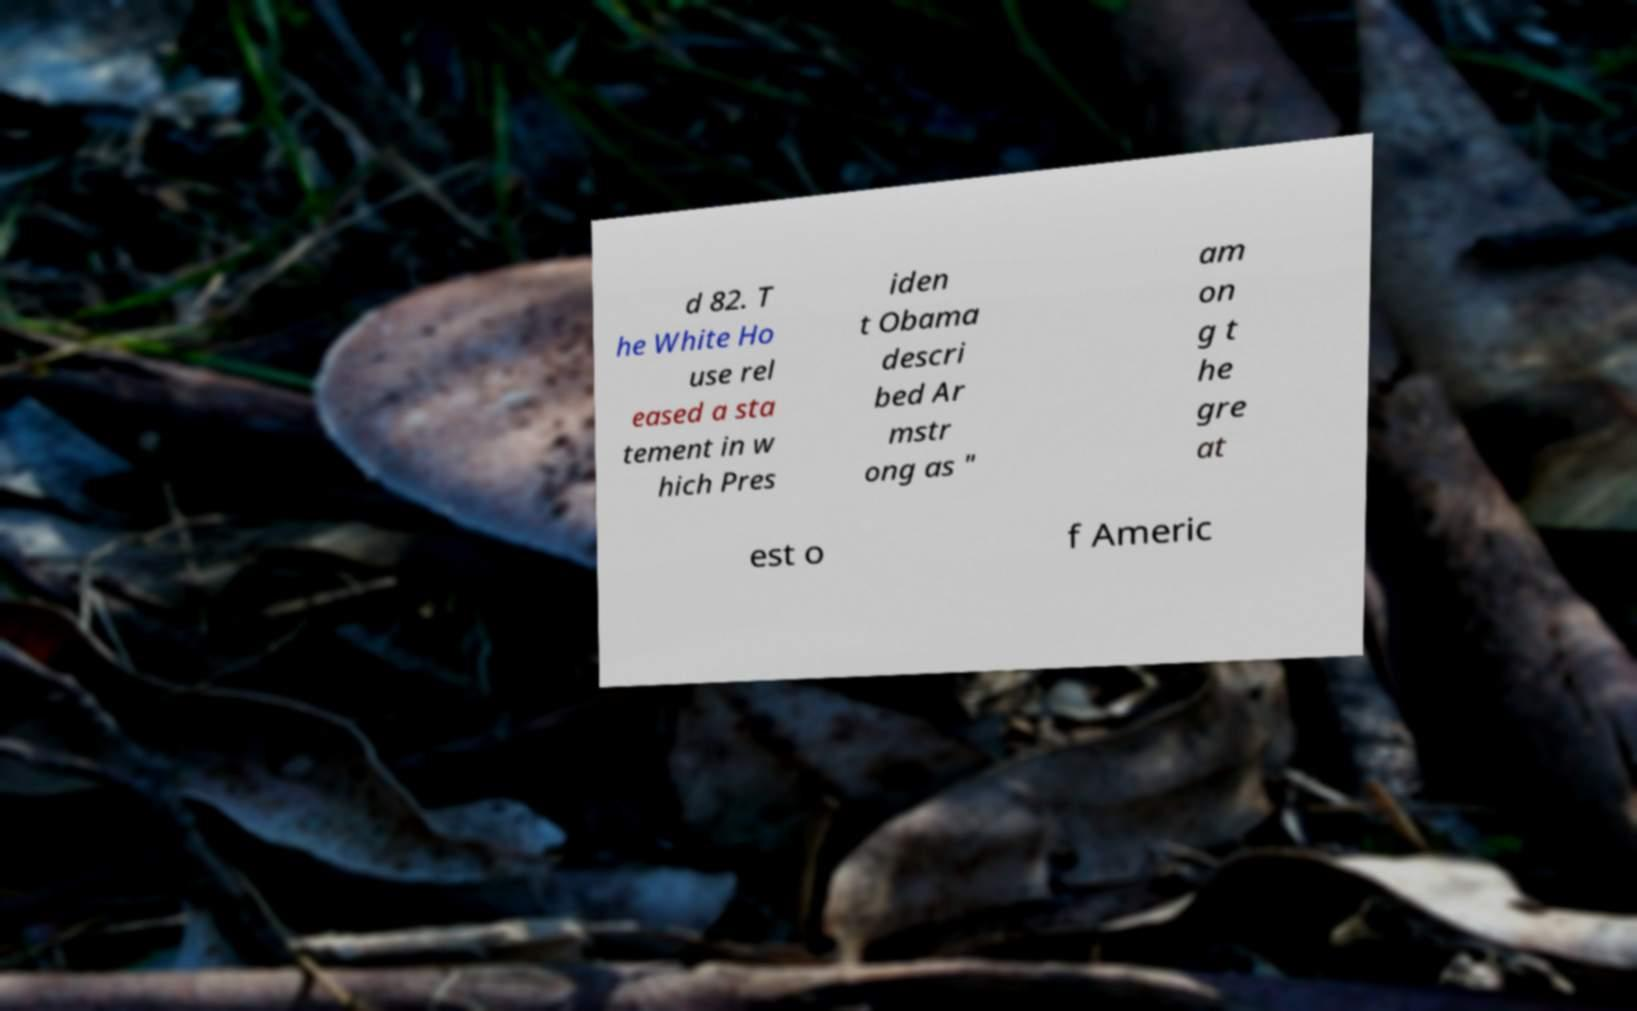Please identify and transcribe the text found in this image. d 82. T he White Ho use rel eased a sta tement in w hich Pres iden t Obama descri bed Ar mstr ong as " am on g t he gre at est o f Americ 